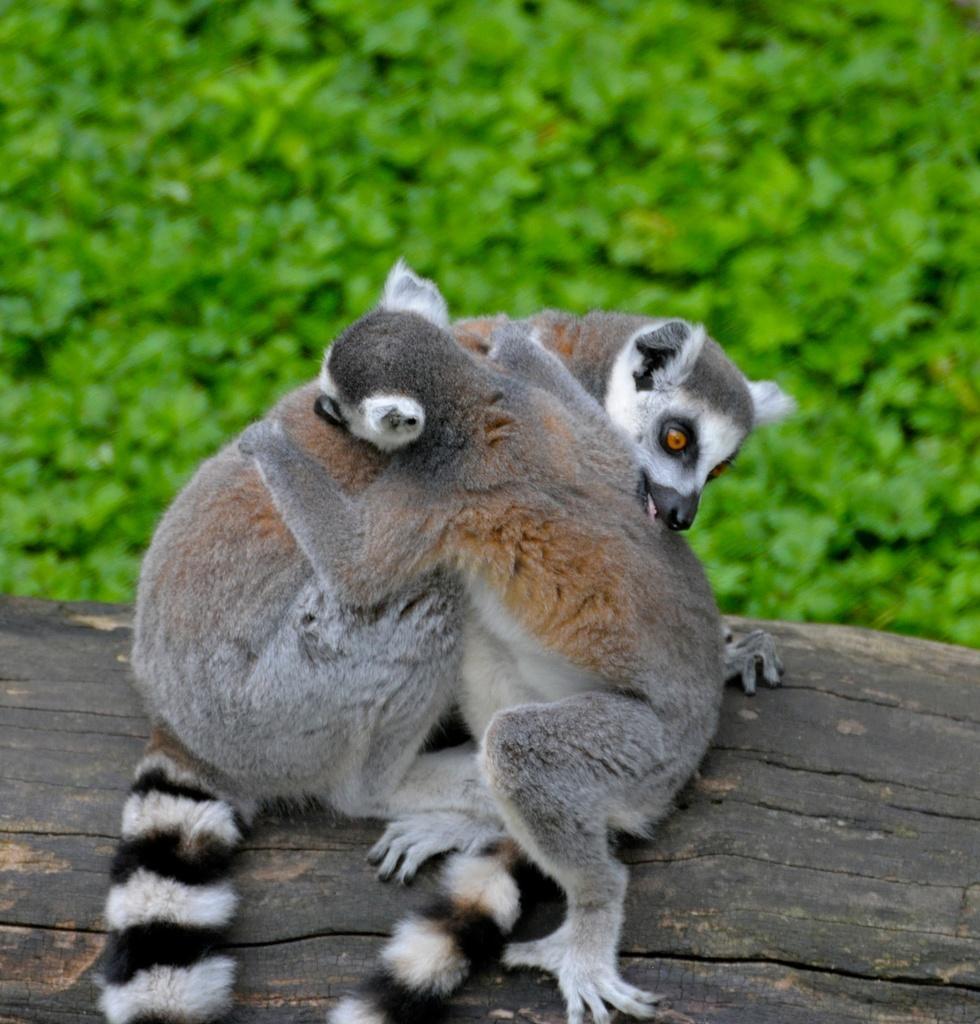Please provide a concise description of this image. In this picture I can see few animals in the middle, in the background there are plants. 